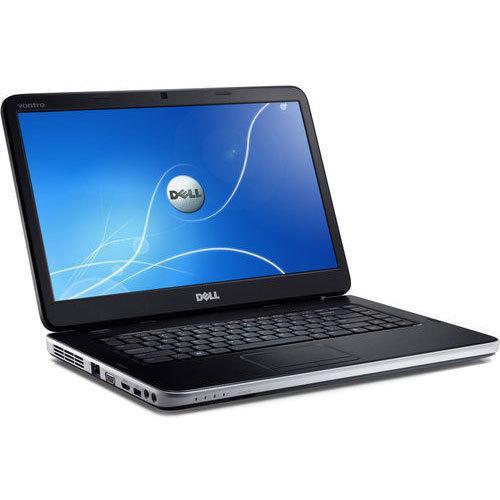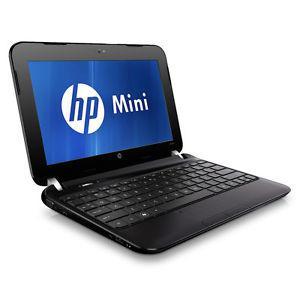The first image is the image on the left, the second image is the image on the right. Given the left and right images, does the statement "At least one image shows a partly open laptop with the screen and keyboard forming less than a 90-degree angle." hold true? Answer yes or no. No. The first image is the image on the left, the second image is the image on the right. Examine the images to the left and right. Is the description "The computers are sitting back to back." accurate? Answer yes or no. No. 